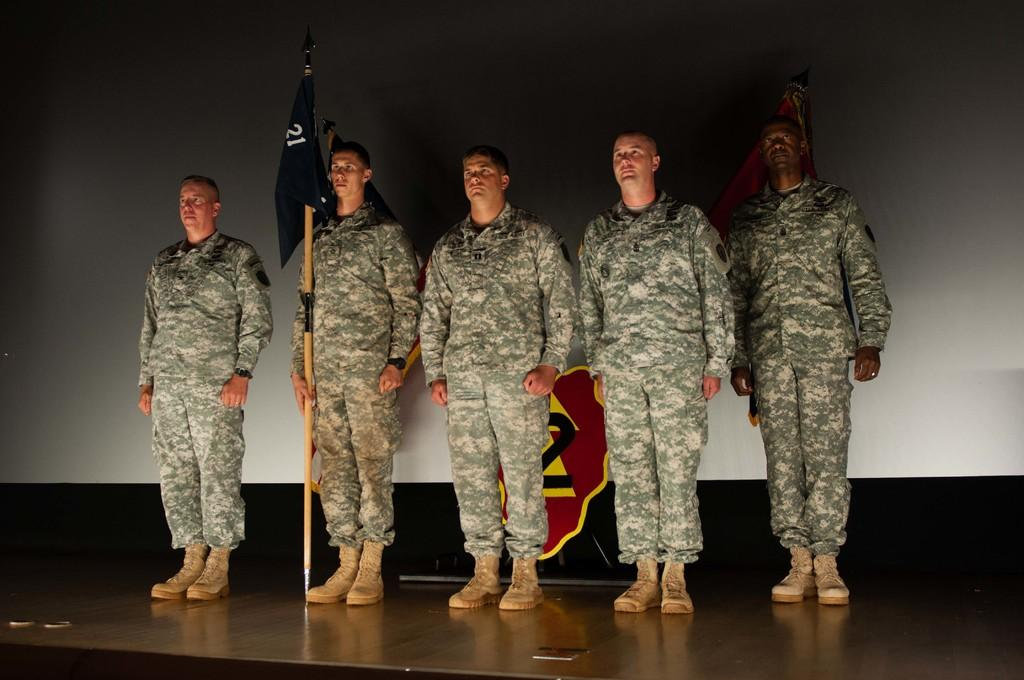How many people are present in the image? There are five people in the image. What are the people wearing? The people are wearing military dress. Can you describe the flag that one person is holding? One person is holding a blue color flag. What can be seen in the background of the image? There is a screen and a flag visible in the background. Where are the people located in the image? The people are on a stage. What type of wool is being spun by the chicken in the image? There is no chicken or wool present in the image. How many waves can be seen crashing on the shore in the image? There is no shore or waves present in the image. 